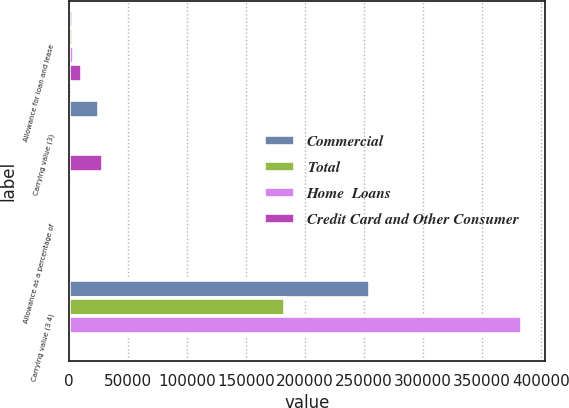Convert chart to OTSL. <chart><loc_0><loc_0><loc_500><loc_500><stacked_bar_chart><ecel><fcel>Allowance for loan and lease<fcel>Carrying value (3)<fcel>Allowance as a percentage of<fcel>Carrying value (3 4)<nl><fcel>Commercial<fcel>3556<fcel>25628<fcel>1.39<fcel>255525<nl><fcel>Total<fcel>3708<fcel>1141<fcel>2.02<fcel>183430<nl><fcel>Home  Loans<fcel>4278<fcel>2198<fcel>1.11<fcel>384019<nl><fcel>Credit Card and Other Consumer<fcel>11542<fcel>28967<fcel>1.4<fcel>1141<nl></chart> 